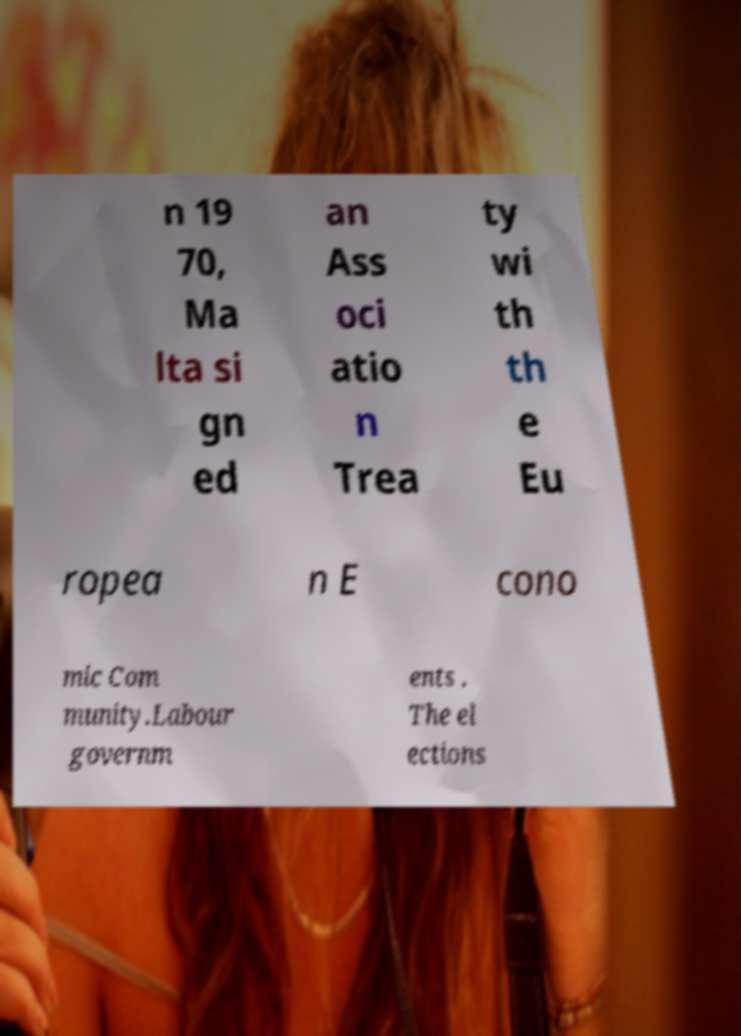Could you extract and type out the text from this image? n 19 70, Ma lta si gn ed an Ass oci atio n Trea ty wi th th e Eu ropea n E cono mic Com munity.Labour governm ents . The el ections 